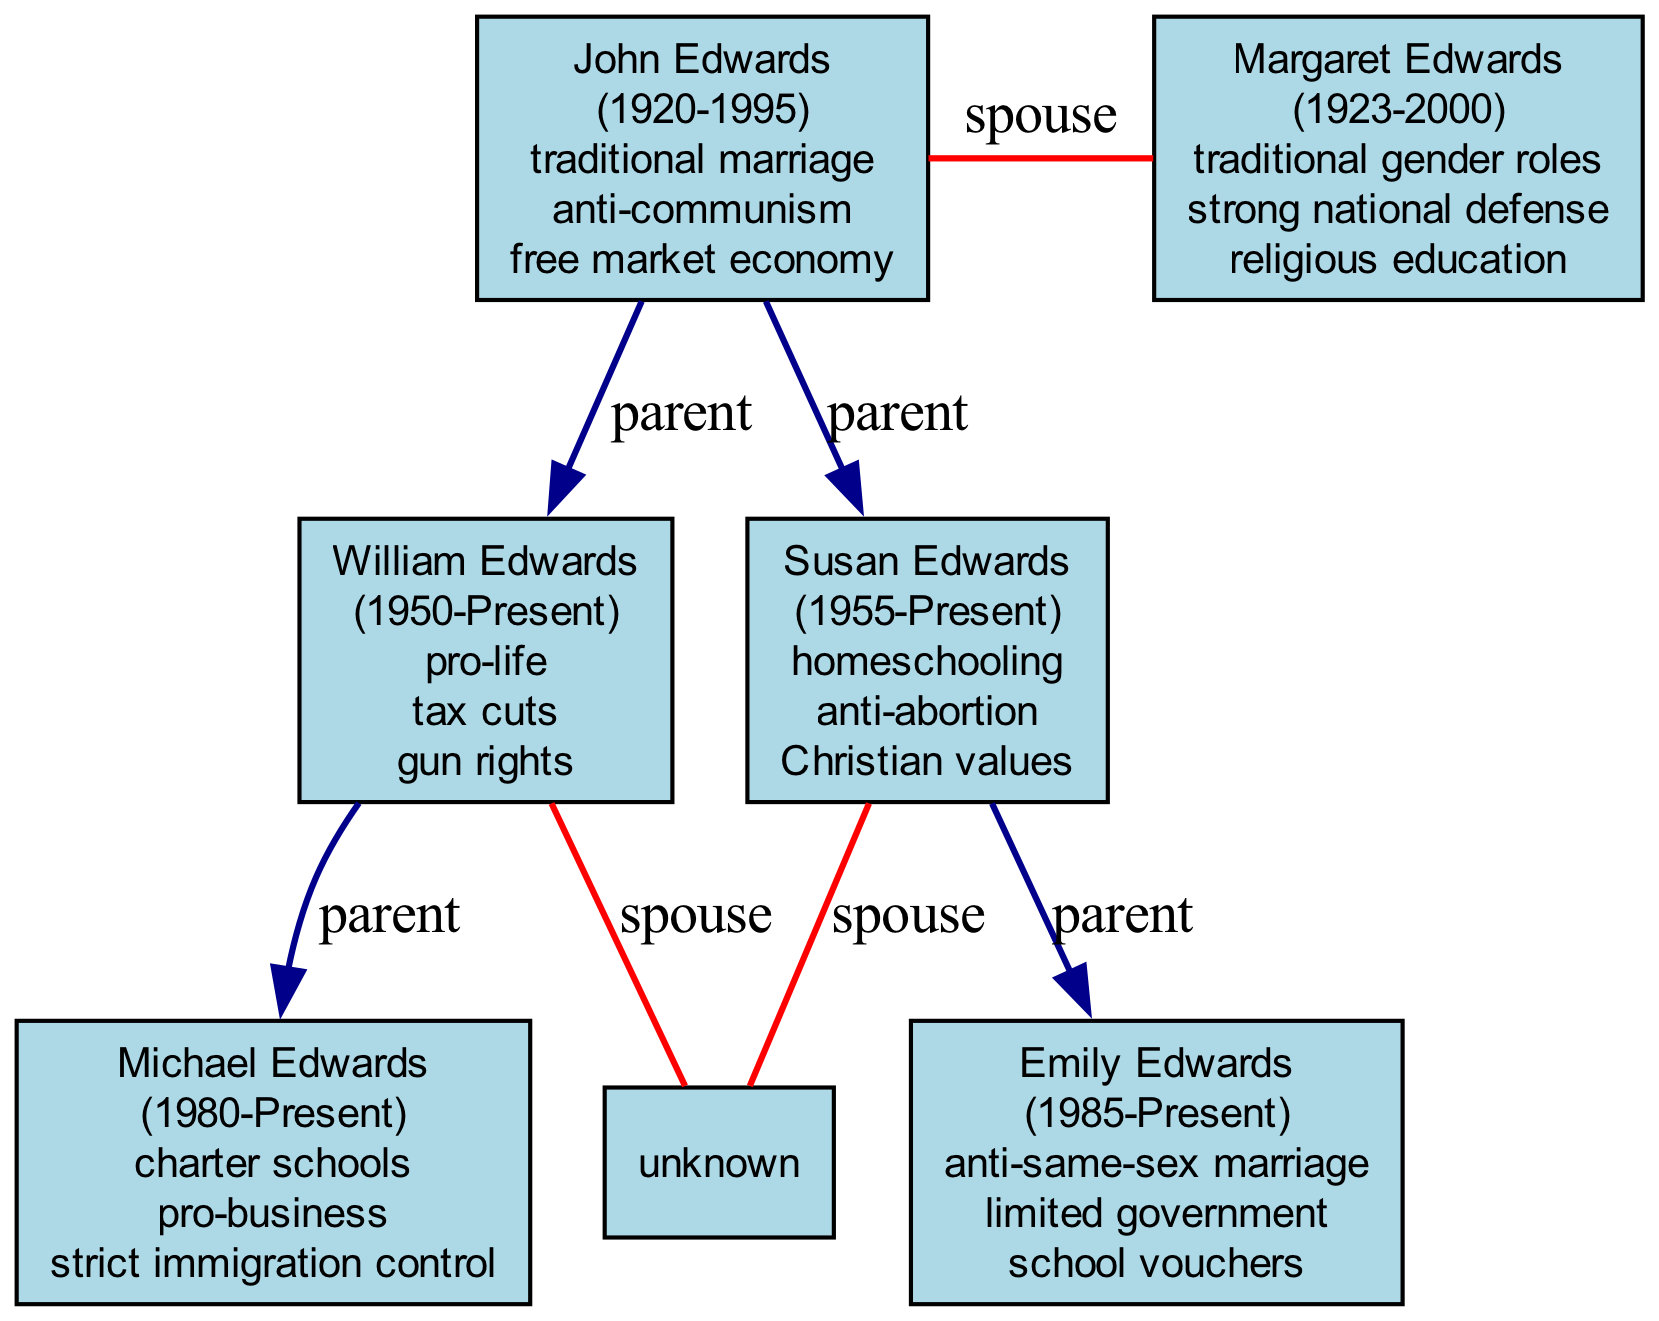What are the social policies of John Edwards? The diagram lists the social policies associated with John Edwards, which are traditional marriage, anti-communism, and free market economy.
Answer: traditional marriage, anti-communism, free market economy Which member was born in 1955? By examining the birth years in the diagram, Susan Edwards is identified with a birth year of 1955.
Answer: Susan Edwards Who are the children of William Edwards? The diagram shows that Michael Edwards is the child of William Edwards, as indicated by their direct parent-child relationship.
Answer: Michael Edwards How many generations are represented in the family tree? The diagram clearly shows three distinct generations, labeled First Generation, Second Generation, and Third Generation.
Answer: 3 What is the social policy of Emily Edwards? The diagram presents Emily Edwards' social policies, which include anti-same-sex marriage, limited government, and school vouchers.
Answer: anti-same-sex marriage, limited government, school vouchers Which member has the social policy related to gun rights? By looking at the members in the Second Generation, it is evident that William Edwards includes gun rights as one of his social policies.
Answer: William Edwards Which two members are spouses? The diagram notes that John Edwards and Margaret Edwards are connected by a spouse relationship.
Answer: John Edwards, Margaret Edwards Who has the social policy of pro-business? The diagram attributes the social policy of pro-business to Michael Edwards, as shown in his listed policies.
Answer: Michael Edwards What is the relationship type between John Edwards and William Edwards? The relationship shown in the diagram between John Edwards and William Edwards is labeled as parent in a child relationship.
Answer: parent 